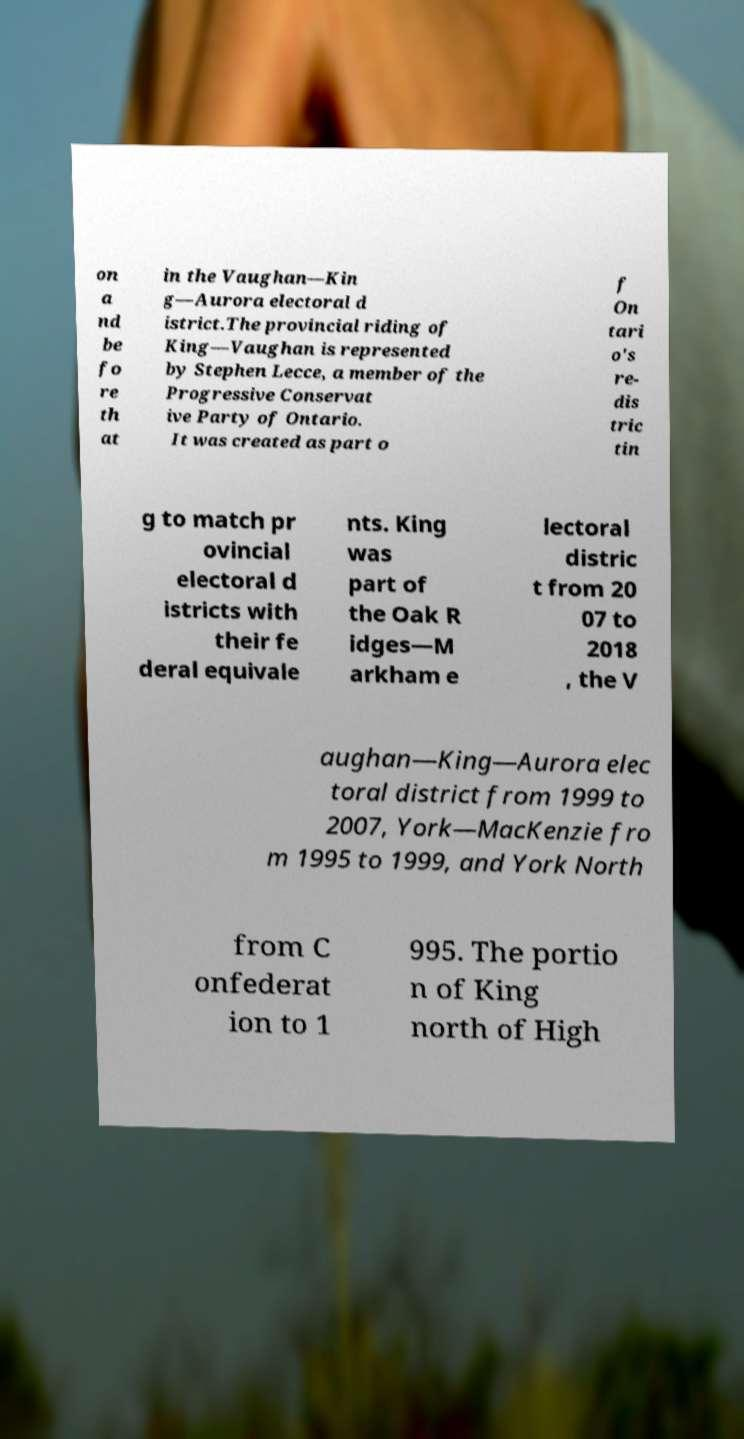Please read and relay the text visible in this image. What does it say? on a nd be fo re th at in the Vaughan—Kin g—Aurora electoral d istrict.The provincial riding of King—Vaughan is represented by Stephen Lecce, a member of the Progressive Conservat ive Party of Ontario. It was created as part o f On tari o's re- dis tric tin g to match pr ovincial electoral d istricts with their fe deral equivale nts. King was part of the Oak R idges—M arkham e lectoral distric t from 20 07 to 2018 , the V aughan—King—Aurora elec toral district from 1999 to 2007, York—MacKenzie fro m 1995 to 1999, and York North from C onfederat ion to 1 995. The portio n of King north of High 